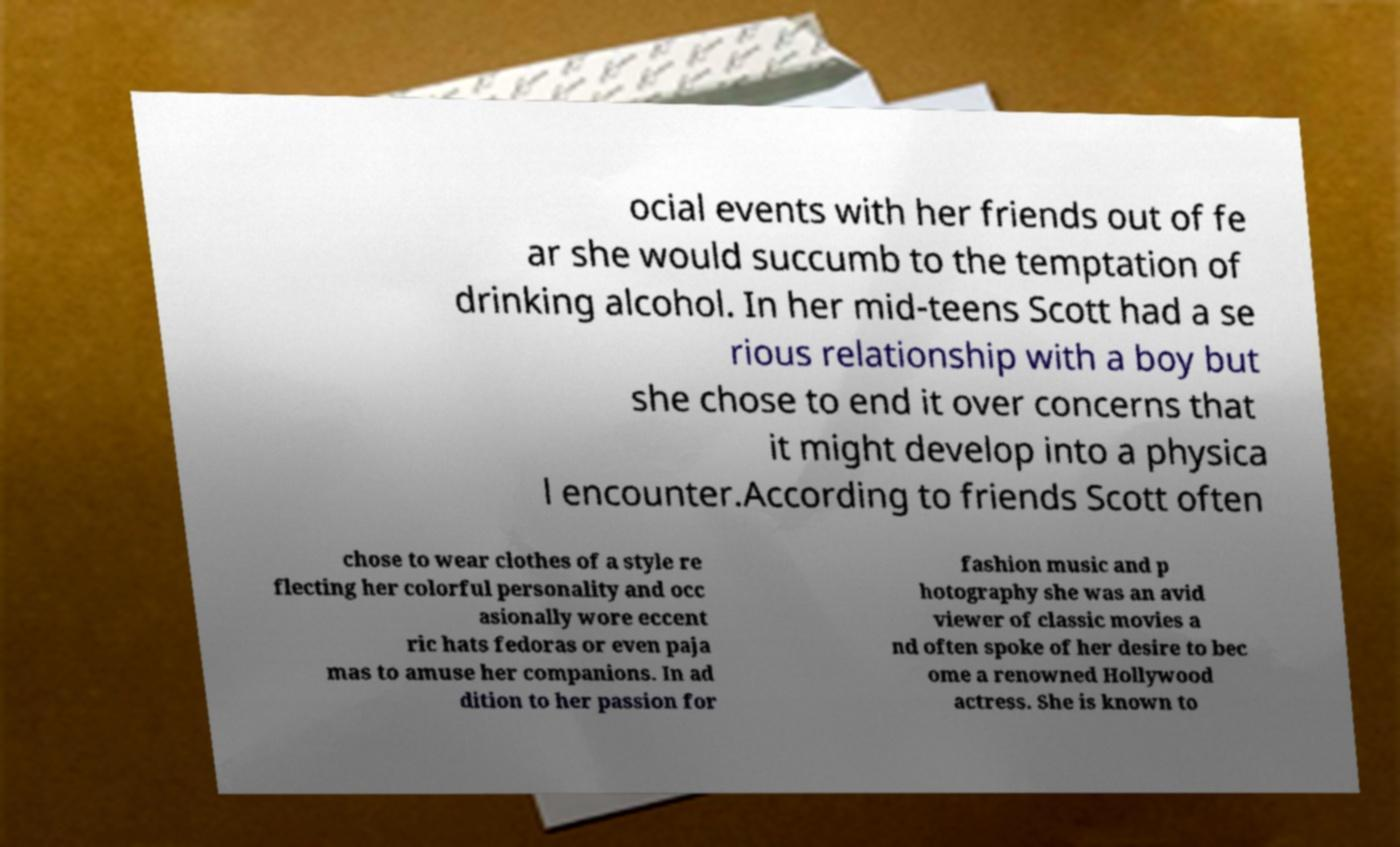Could you extract and type out the text from this image? ocial events with her friends out of fe ar she would succumb to the temptation of drinking alcohol. In her mid-teens Scott had a se rious relationship with a boy but she chose to end it over concerns that it might develop into a physica l encounter.According to friends Scott often chose to wear clothes of a style re flecting her colorful personality and occ asionally wore eccent ric hats fedoras or even paja mas to amuse her companions. In ad dition to her passion for fashion music and p hotography she was an avid viewer of classic movies a nd often spoke of her desire to bec ome a renowned Hollywood actress. She is known to 